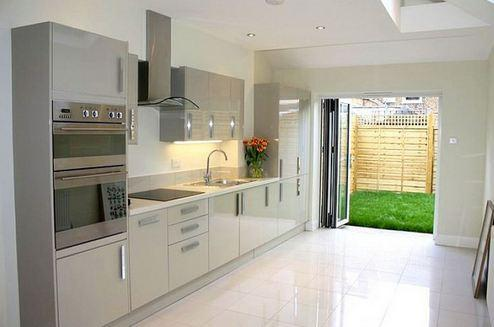What is the green object on top of the counter to the right of the sink? flowers 